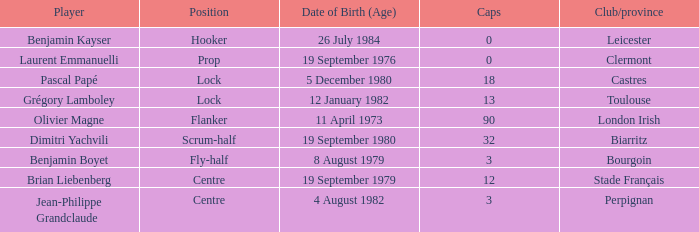Parse the full table. {'header': ['Player', 'Position', 'Date of Birth (Age)', 'Caps', 'Club/province'], 'rows': [['Benjamin Kayser', 'Hooker', '26 July 1984', '0', 'Leicester'], ['Laurent Emmanuelli', 'Prop', '19 September 1976', '0', 'Clermont'], ['Pascal Papé', 'Lock', '5 December 1980', '18', 'Castres'], ['Grégory Lamboley', 'Lock', '12 January 1982', '13', 'Toulouse'], ['Olivier Magne', 'Flanker', '11 April 1973', '90', 'London Irish'], ['Dimitri Yachvili', 'Scrum-half', '19 September 1980', '32', 'Biarritz'], ['Benjamin Boyet', 'Fly-half', '8 August 1979', '3', 'Bourgoin'], ['Brian Liebenberg', 'Centre', '19 September 1979', '12', 'Stade Français'], ['Jean-Philippe Grandclaude', 'Centre', '4 August 1982', '3', 'Perpignan']]} What is the location of perpignan? Centre. 